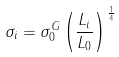Convert formula to latex. <formula><loc_0><loc_0><loc_500><loc_500>\sigma _ { i } = \sigma _ { 0 } ^ { G } \left ( \frac { L _ { i } } { L _ { 0 } } \right ) ^ { \frac { 1 } { 4 } }</formula> 